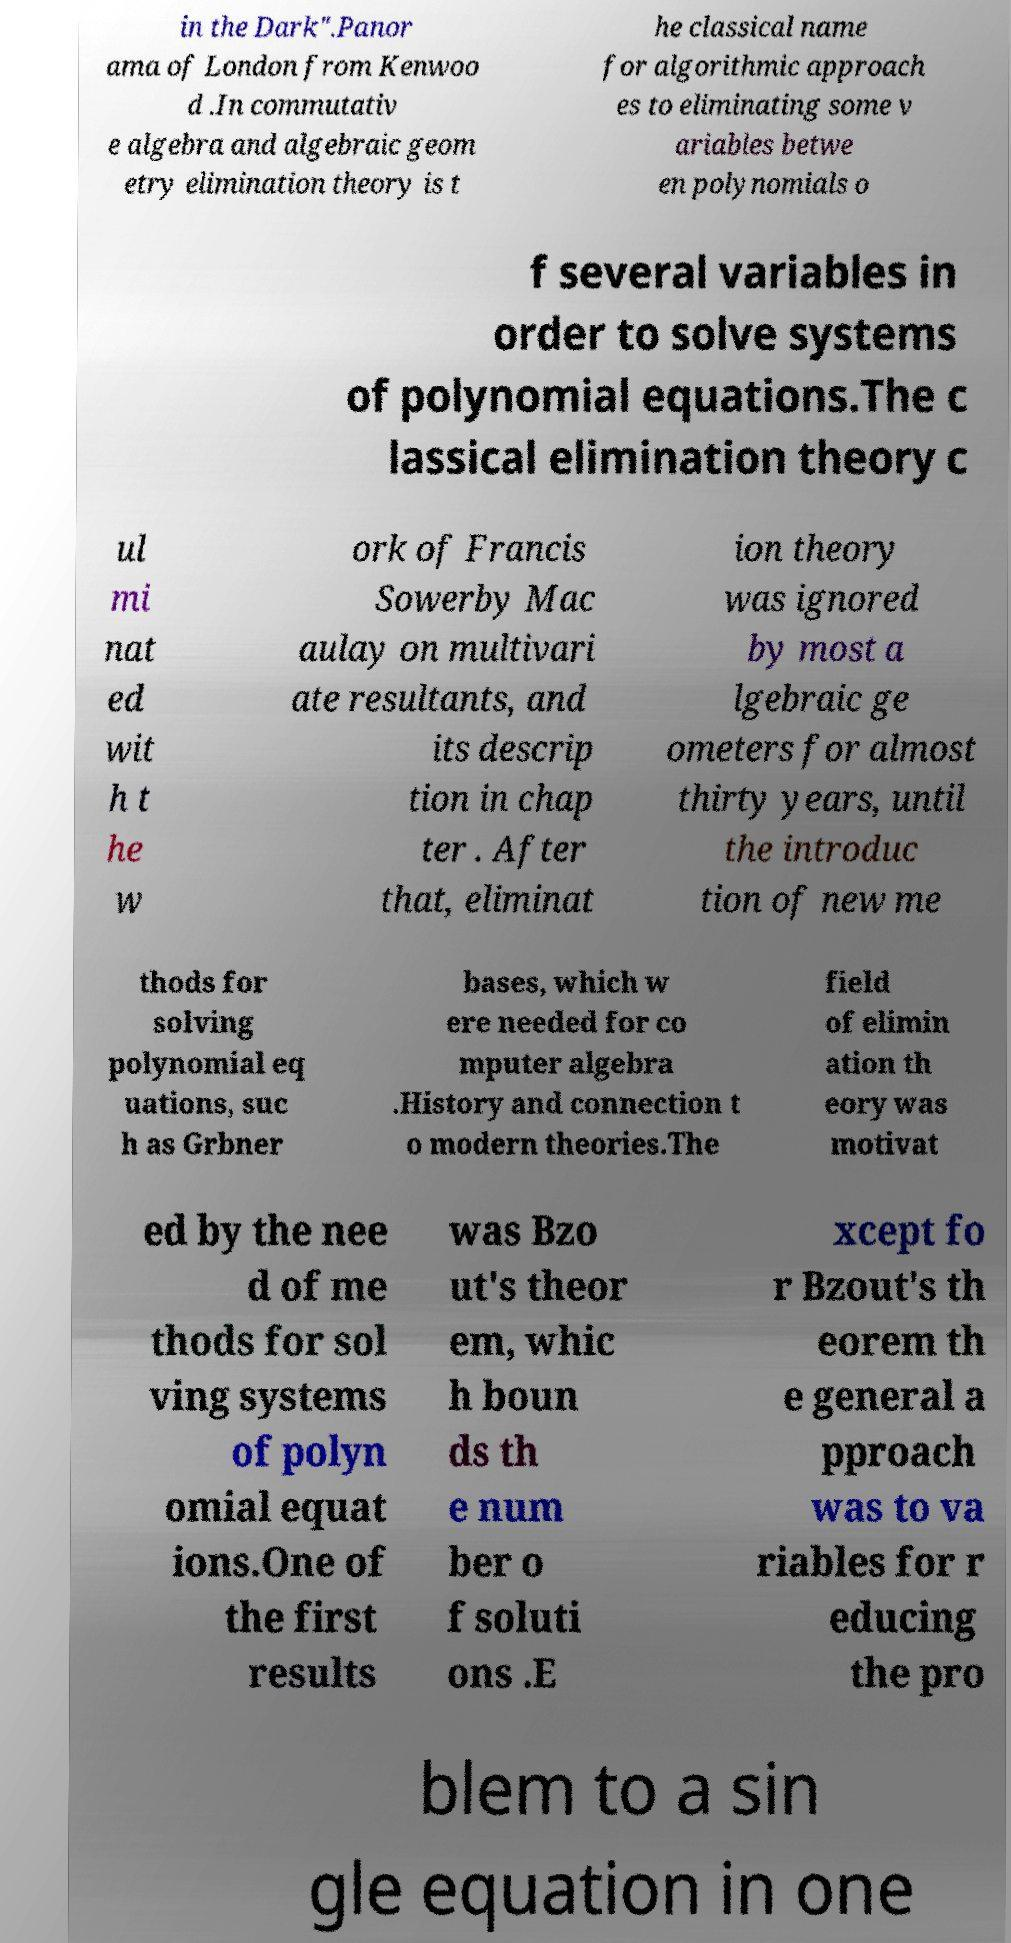Could you extract and type out the text from this image? in the Dark".Panor ama of London from Kenwoo d .In commutativ e algebra and algebraic geom etry elimination theory is t he classical name for algorithmic approach es to eliminating some v ariables betwe en polynomials o f several variables in order to solve systems of polynomial equations.The c lassical elimination theory c ul mi nat ed wit h t he w ork of Francis Sowerby Mac aulay on multivari ate resultants, and its descrip tion in chap ter . After that, eliminat ion theory was ignored by most a lgebraic ge ometers for almost thirty years, until the introduc tion of new me thods for solving polynomial eq uations, suc h as Grbner bases, which w ere needed for co mputer algebra .History and connection t o modern theories.The field of elimin ation th eory was motivat ed by the nee d of me thods for sol ving systems of polyn omial equat ions.One of the first results was Bzo ut's theor em, whic h boun ds th e num ber o f soluti ons .E xcept fo r Bzout's th eorem th e general a pproach was to va riables for r educing the pro blem to a sin gle equation in one 